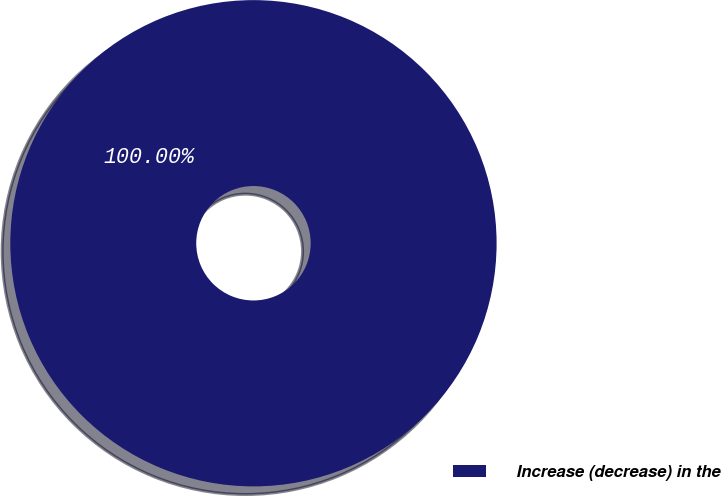Convert chart to OTSL. <chart><loc_0><loc_0><loc_500><loc_500><pie_chart><fcel>Increase (decrease) in the<nl><fcel>100.0%<nl></chart> 